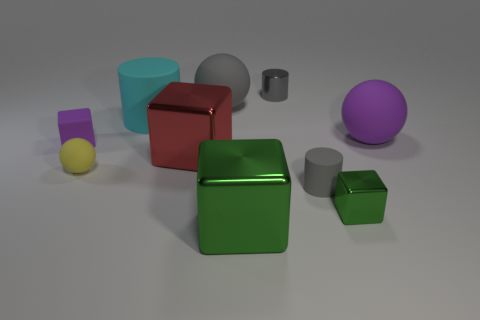Does the block right of the large green block have the same material as the purple cube?
Offer a terse response. No. Does the cylinder that is in front of the yellow thing have the same color as the small metal cylinder?
Provide a succinct answer. Yes. Are there any big purple matte objects of the same shape as the big gray matte object?
Give a very brief answer. Yes. Is the color of the metallic cylinder the same as the small matte cylinder?
Offer a very short reply. Yes. How many tiny things are either cyan cylinders or purple spheres?
Keep it short and to the point. 0. Are there any other things of the same color as the tiny rubber cylinder?
Your response must be concise. Yes. There is a yellow object; are there any small rubber things on the left side of it?
Your answer should be very brief. Yes. What is the size of the matte sphere right of the large gray ball right of the small purple object?
Provide a succinct answer. Large. Are there an equal number of small gray rubber cylinders in front of the big red object and purple matte objects behind the tiny gray metallic cylinder?
Give a very brief answer. No. Is there a metallic cube to the left of the sphere that is behind the large matte cylinder?
Your answer should be very brief. Yes. 